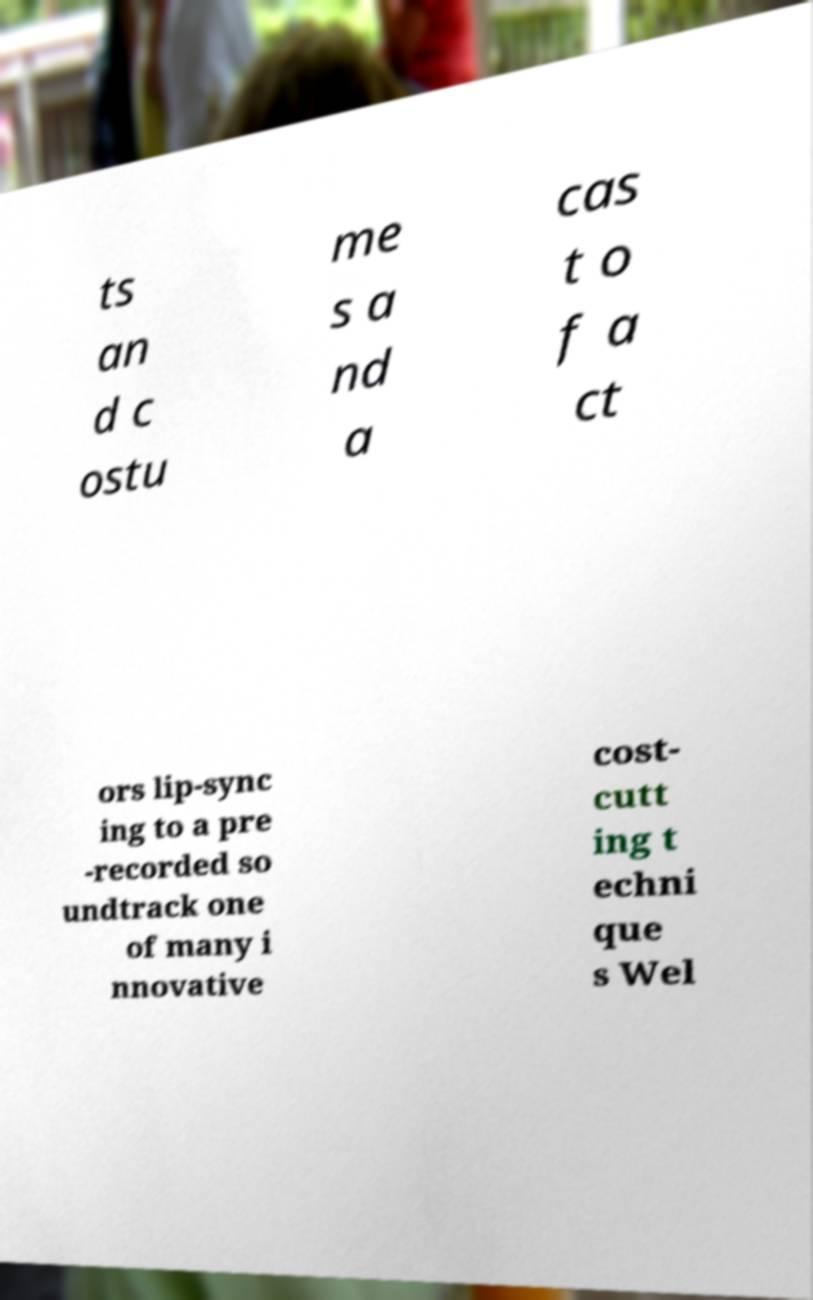For documentation purposes, I need the text within this image transcribed. Could you provide that? ts an d c ostu me s a nd a cas t o f a ct ors lip-sync ing to a pre -recorded so undtrack one of many i nnovative cost- cutt ing t echni que s Wel 